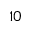<formula> <loc_0><loc_0><loc_500><loc_500>_ { 1 0 }</formula> 